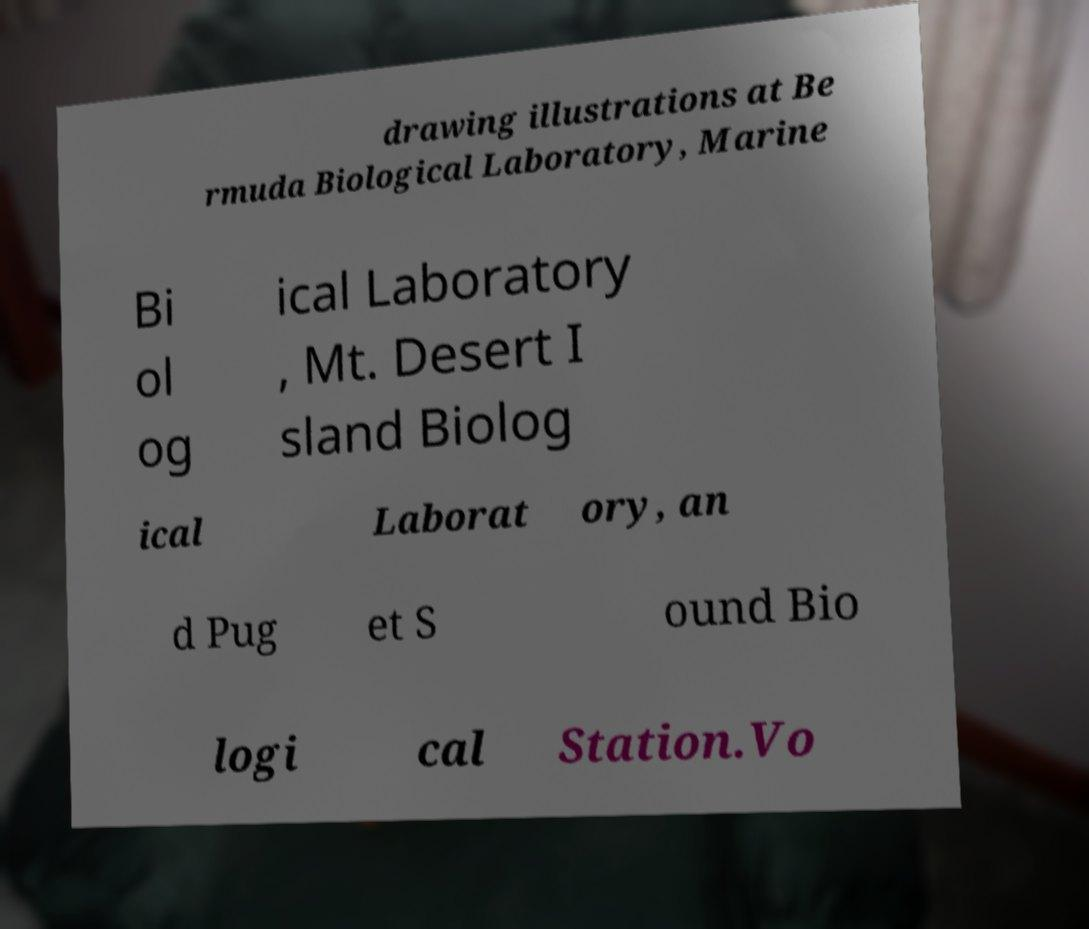Can you accurately transcribe the text from the provided image for me? drawing illustrations at Be rmuda Biological Laboratory, Marine Bi ol og ical Laboratory , Mt. Desert I sland Biolog ical Laborat ory, an d Pug et S ound Bio logi cal Station.Vo 